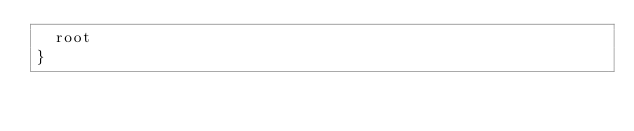<code> <loc_0><loc_0><loc_500><loc_500><_Kotlin_>  root
}
</code> 